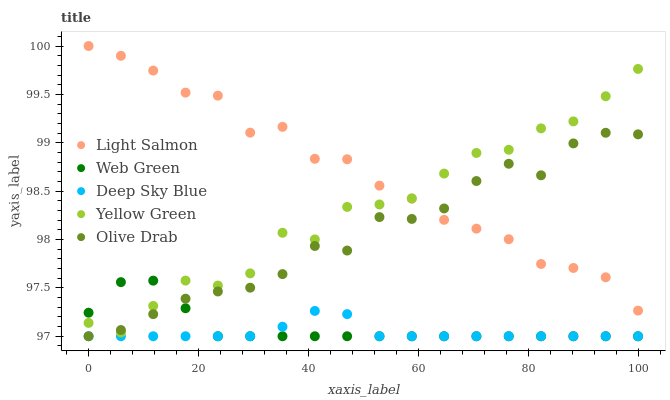Does Deep Sky Blue have the minimum area under the curve?
Answer yes or no. Yes. Does Light Salmon have the maximum area under the curve?
Answer yes or no. Yes. Does Light Salmon have the minimum area under the curve?
Answer yes or no. No. Does Deep Sky Blue have the maximum area under the curve?
Answer yes or no. No. Is Deep Sky Blue the smoothest?
Answer yes or no. Yes. Is Yellow Green the roughest?
Answer yes or no. Yes. Is Light Salmon the smoothest?
Answer yes or no. No. Is Light Salmon the roughest?
Answer yes or no. No. Does Olive Drab have the lowest value?
Answer yes or no. Yes. Does Light Salmon have the lowest value?
Answer yes or no. No. Does Light Salmon have the highest value?
Answer yes or no. Yes. Does Deep Sky Blue have the highest value?
Answer yes or no. No. Is Deep Sky Blue less than Yellow Green?
Answer yes or no. Yes. Is Light Salmon greater than Deep Sky Blue?
Answer yes or no. Yes. Does Yellow Green intersect Olive Drab?
Answer yes or no. Yes. Is Yellow Green less than Olive Drab?
Answer yes or no. No. Is Yellow Green greater than Olive Drab?
Answer yes or no. No. Does Deep Sky Blue intersect Yellow Green?
Answer yes or no. No. 